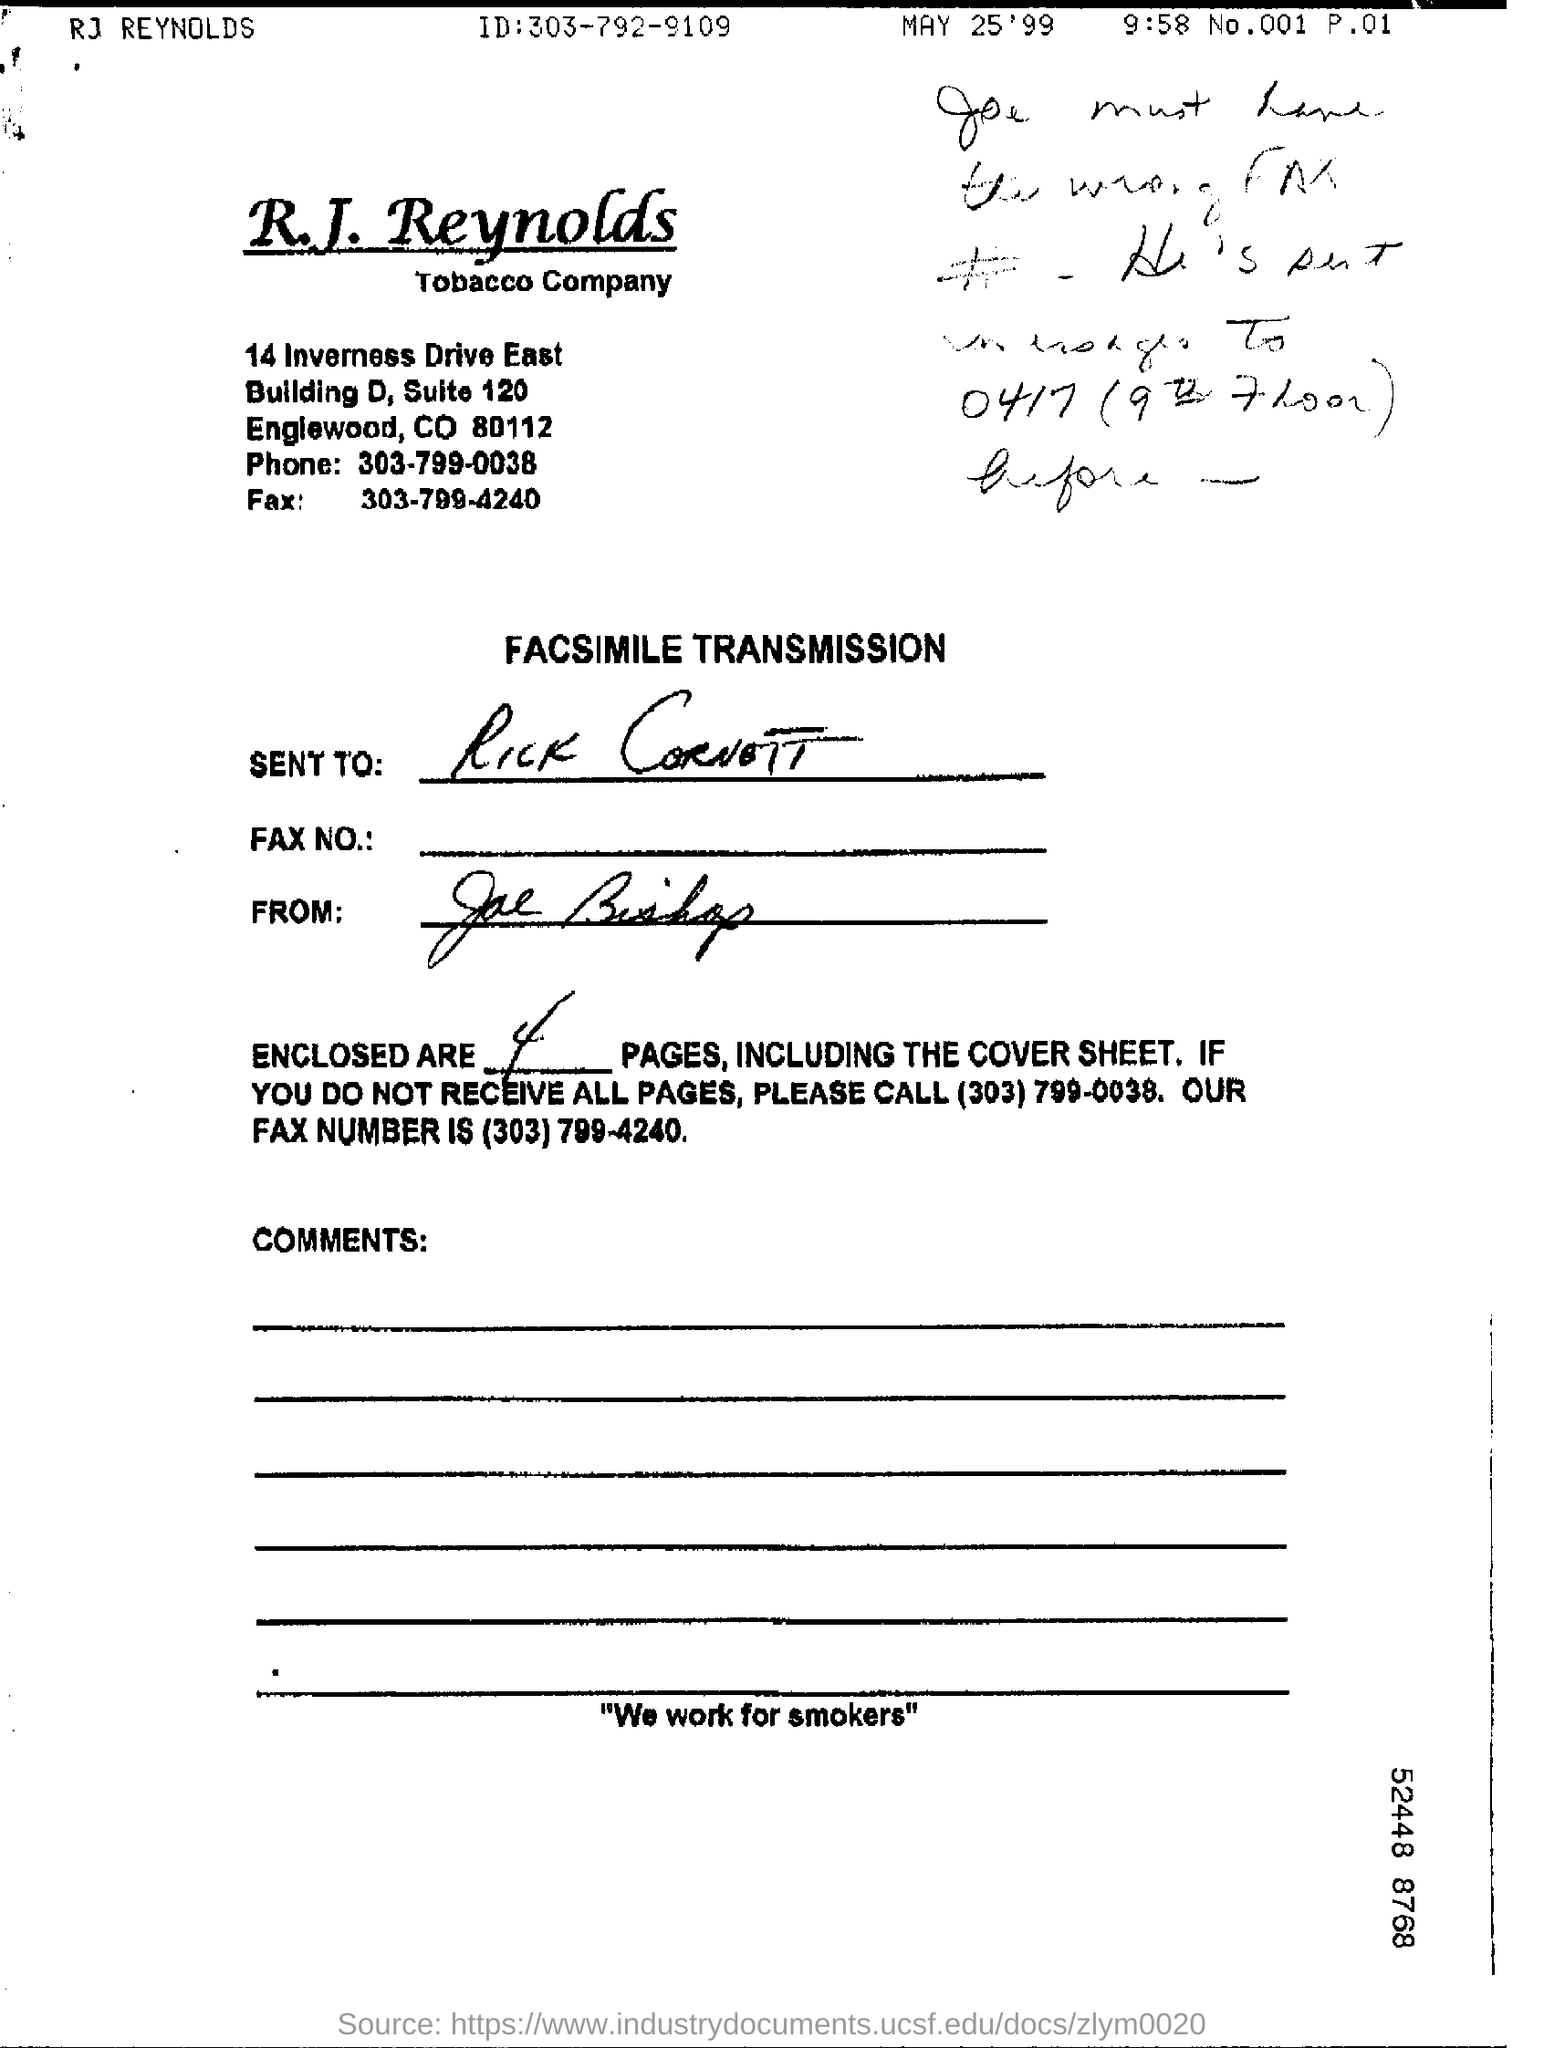What is the contact number of phone for r.j. reynolds?
Your answer should be compact. 303-799-0038. What is the name of tobacco company?
Give a very brief answer. R.J reynolds. How many no of pages are including the cover sheet?
Offer a very short reply. 4. What kind of transmission?
Give a very brief answer. Facsimile transmission. 